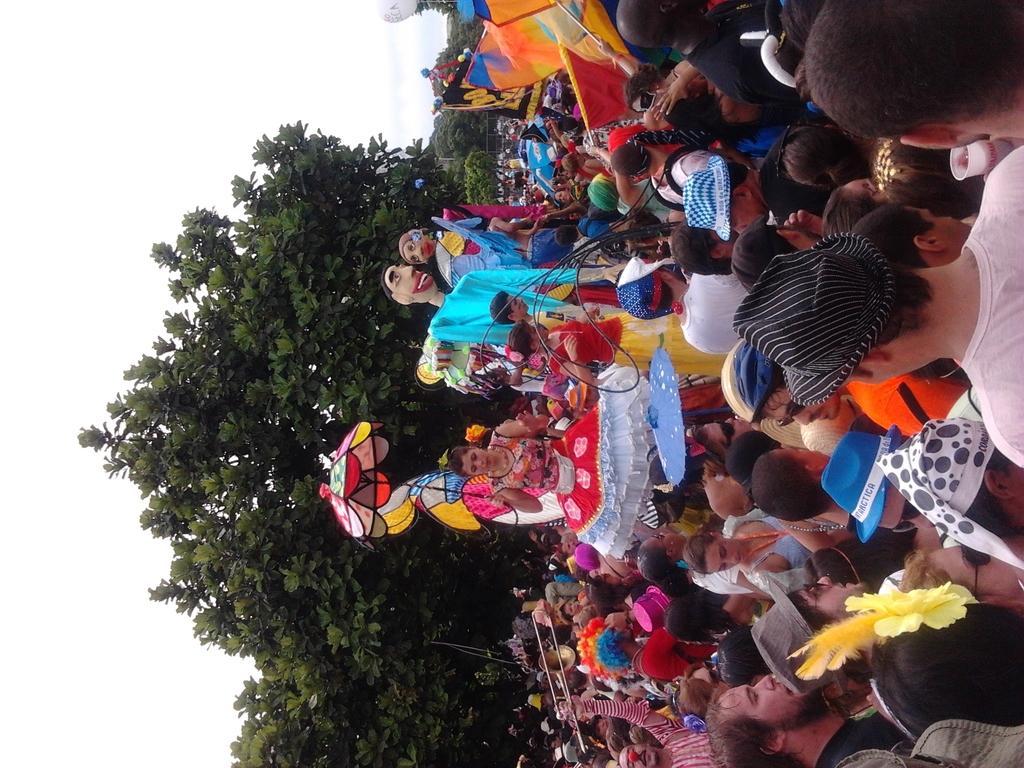Can you describe this image briefly? In this image we can see people standing standing on the road and some are wearing costumes. In the background there are trees and sky. 